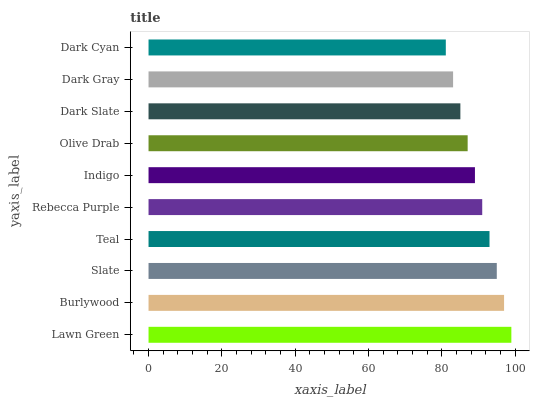Is Dark Cyan the minimum?
Answer yes or no. Yes. Is Lawn Green the maximum?
Answer yes or no. Yes. Is Burlywood the minimum?
Answer yes or no. No. Is Burlywood the maximum?
Answer yes or no. No. Is Lawn Green greater than Burlywood?
Answer yes or no. Yes. Is Burlywood less than Lawn Green?
Answer yes or no. Yes. Is Burlywood greater than Lawn Green?
Answer yes or no. No. Is Lawn Green less than Burlywood?
Answer yes or no. No. Is Rebecca Purple the high median?
Answer yes or no. Yes. Is Indigo the low median?
Answer yes or no. Yes. Is Dark Slate the high median?
Answer yes or no. No. Is Dark Slate the low median?
Answer yes or no. No. 